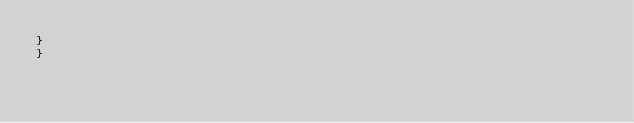<code> <loc_0><loc_0><loc_500><loc_500><_Cuda_>}
}
</code> 